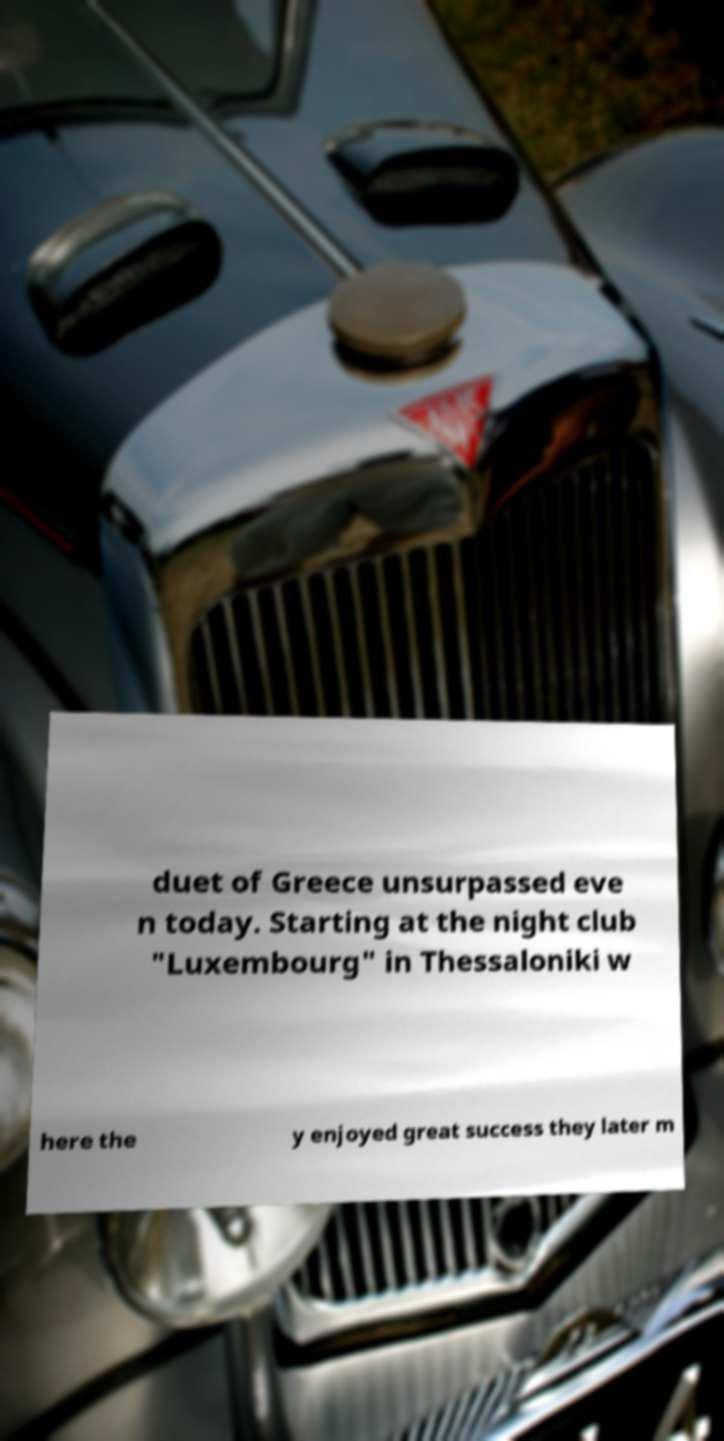For documentation purposes, I need the text within this image transcribed. Could you provide that? duet of Greece unsurpassed eve n today. Starting at the night club "Luxembourg" in Thessaloniki w here the y enjoyed great success they later m 